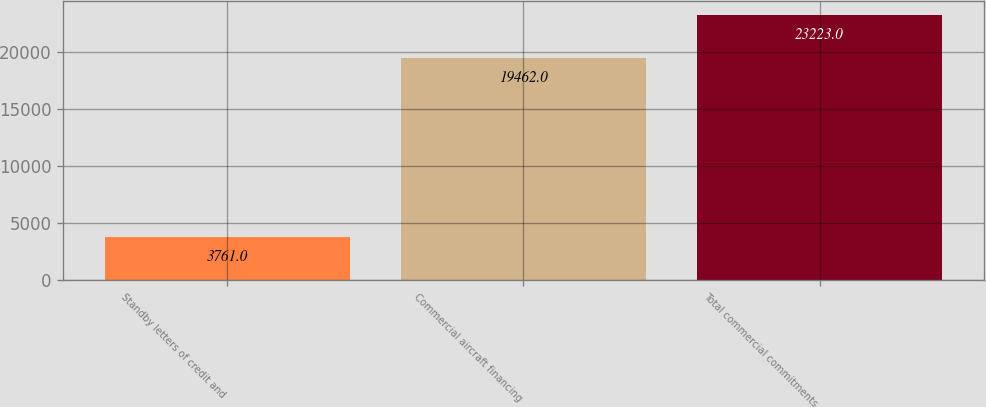<chart> <loc_0><loc_0><loc_500><loc_500><bar_chart><fcel>Standby letters of credit and<fcel>Commercial aircraft financing<fcel>Total commercial commitments<nl><fcel>3761<fcel>19462<fcel>23223<nl></chart> 